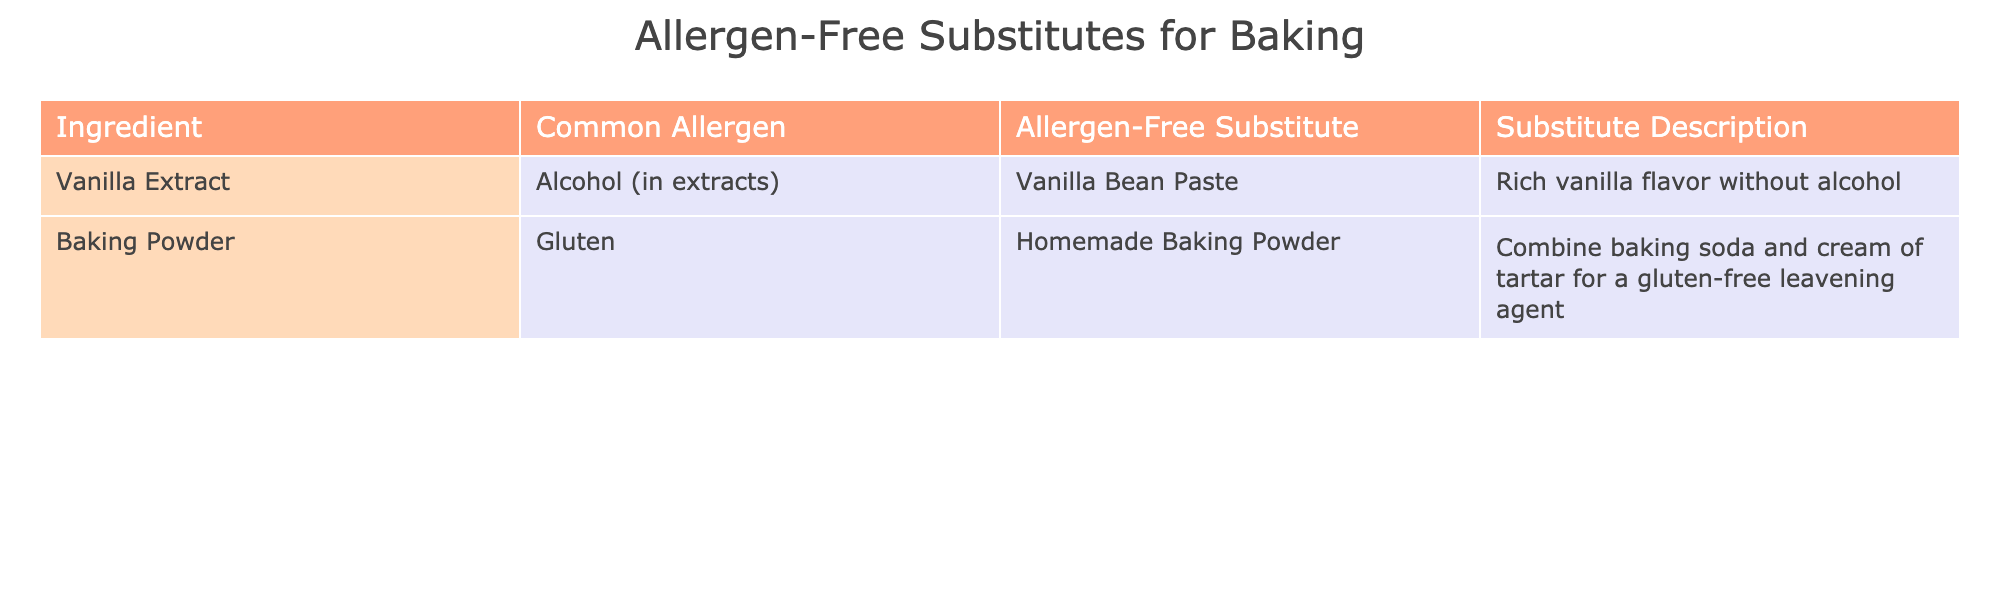What is the allergen-free substitute for vanilla extract? The table directly lists the allergen-free substitute for vanilla extract as vanilla bean paste.
Answer: Vanilla bean paste What common allergen is associated with baking powder? The table indicates that the common allergen associated with baking powder is gluten.
Answer: Gluten How many allergen-free substitutes are shown in the table? The table contains 2 rows of data, each representing an allergen-free substitute for a common baking ingredient.
Answer: 2 Is vanilla bean paste alcohol-free? Given that vanilla extract contains alcohol, and the table lists vanilla bean paste as a substitute, it implies that vanilla bean paste does not contain alcohol.
Answer: Yes What can be combined to make homemade baking powder? The table states that homemade baking powder can be made by combining baking soda and cream of tartar.
Answer: Baking soda and cream of tartar Which allergen-free substitute offers a rich vanilla flavor? The table specifies that vanilla bean paste provides a rich vanilla flavor as an allergen-free substitute for vanilla extract.
Answer: Vanilla bean paste If I wanted to avoid both gluten and alcohol, what should I use in my recipe instead of baking powder and vanilla extract? To avoid gluten and alcohol, you would use homemade baking powder (made with baking soda and cream of tartar) and vanilla bean paste. This requires recognizing both substitutes from the table.
Answer: Homemade baking powder and vanilla bean paste What is the relationship between gluten and baking powder in terms of allergen classification? According to the table, baking powder is directly associated with gluten as its common allergen, indicating that avoiding baking powder would help avoid gluten for those allergic to it.
Answer: Baking powder contains gluten 